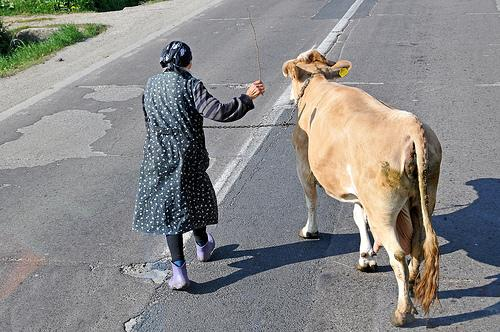Mention the color of the shoes and socks that the woman is wearing in this image. The woman is wearing purple shoes and blue socks. Deduce the sentiment or emotion that the image might convey, based on the image. The image might convey a sense of calmness as the woman is walking a cow down a street, potentially engaging in a rural or countryside activity. Evaluate the significance of the line in the road based on the information provided in the image. The line in the road seems to be a part of the street's design, possibly indicating traffic flow, and it occupies a medium-sized section of the image. Please list three tasks that can be performed using the image given for this image. Object detection task, object interaction analysis task, and object counting task. Describe the cow and its features in the image using the image. The brown cow is wearing a chain and has a brown tail and a left ear that can be seen in the image. Examine the scene with the woman and the cow and identify the kind of interaction they have. The woman is walking a cow down the street, implying a relationship between the woman and the cow, potentially as a caretaker or an owner. List down the primary objects mentioned in the image. Woman, shoes, socks, dress, boots, cow, chain, coat, scarf, stick, road, grass, bandana, and rock. Describe the woman's appearance in the image based on the image. The woman is wearing a dress, a blue coat, purple shoes or socks, and a scarf or bandana on her head. She's also holding a stick in her hand. Explain the overall scenery of the image based on the image details. A woman is walking a brown cow down a street with a line in the middle, wearing a dress, coat, bandana, shoes, and socks. There's a small part of a gray rock and some grass on the side of the road. Can you see the red cat sitting on the roof of the house in the background? The presence of a red cat on the roof really adds a sense of playfulness to the scene. Provide a detailed account of the woman's clothing and accessories. The woman is wearing a blue coat, a scarf on her head, purple boots, socks, and is holding a stick. Create a multi-modal narrative based on the image. On a sunny day in a tranquil neighborhood, a sprightly woman wearing a blue and white jacket, purple boots, and a scarf on her head confidently strides alongside a brown cow. The picturesque environment is enhanced by the green grass on the side of the road and the small gray rocks. Can you spot the pink umbrella the woman is holding in her left hand? The woman is not holding a pink umbrella in her left hand. What is the woman holding in her hand? A stick. What color are the socks the woman is wearing? Blue. Describe the woman's facial accessory and footwear. The woman sports a bandana on her head and wears purple boots. Identify the main activity shown in the image. A woman walking a cow. What do you think the woman is cooking in the orange pot on the right side of the street? The orange pot really seems to be filled with some delicious food. Notice the golden watch on the lady's right wrist, it seems pretty expensive. The lady must have spent a fortune on that golden watch she has on her right wrist. What type of animal is in the image? Cow. Does the image contain a woman wearing purple shoes, red shoes, or blue shoes? Purple shoes. What type of footwear does the woman have on? Purple boots. Identify the color of the grass on the side of the road. Green. Have you seen the green bicycle parked right beside the cow? That green bicycle really adds a pop of color to the scene. Identify the color of the woman's jacket. Blue and white. Provide a stylish description of the woman's attire. A chic woman donning a blue coat, purple boots, and a scarf on her head walks alongside a cow. Examine the structures and elements in the scene for diagram understanding. It is an outdoor scene with no diagrams to interpret. What event is happening in the image? A woman is taking a cow for a walk down the street. Describe the object in the middle of the road. There's a line in the middle of the road. What color are the shoes the woman is wearing? Purple. What do you think about the yellow hat the cow is wearing? The cow's yellow hat really complements its brown color. What color is the tail of the cow? Brown. Read the text on any object in the picture. There is no text in the image. 